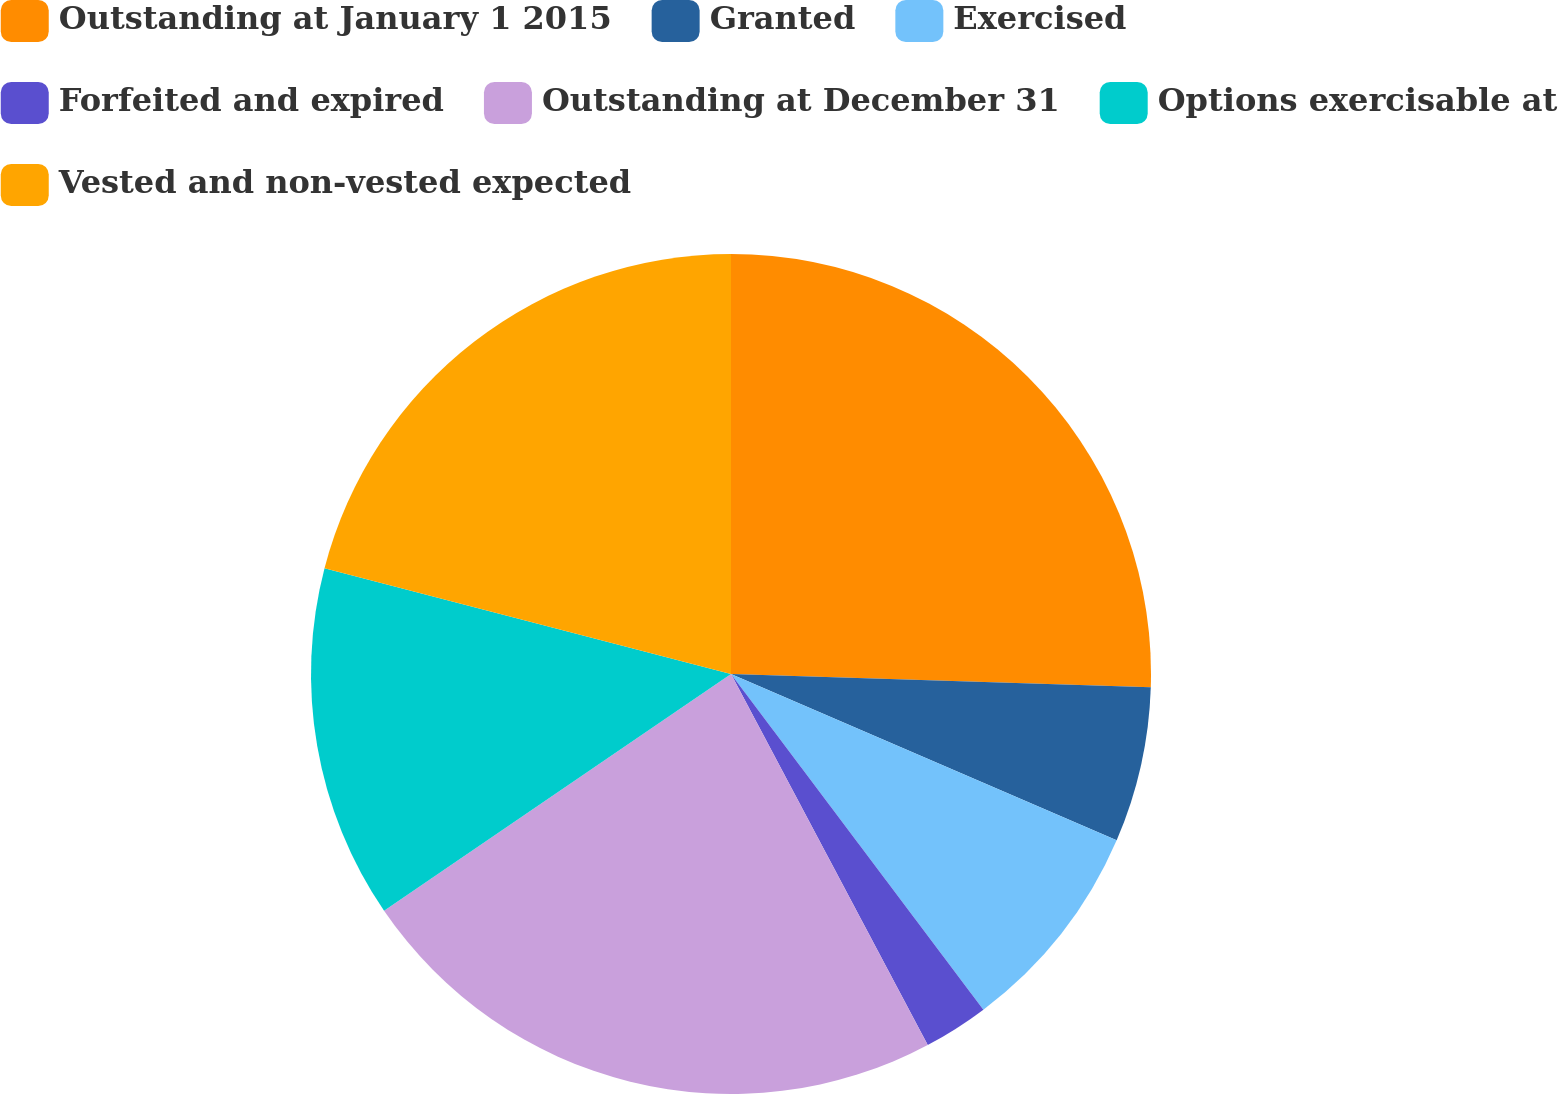Convert chart to OTSL. <chart><loc_0><loc_0><loc_500><loc_500><pie_chart><fcel>Outstanding at January 1 2015<fcel>Granted<fcel>Exercised<fcel>Forfeited and expired<fcel>Outstanding at December 31<fcel>Options exercisable at<fcel>Vested and non-vested expected<nl><fcel>25.5%<fcel>5.98%<fcel>8.26%<fcel>2.5%<fcel>23.23%<fcel>13.58%<fcel>20.95%<nl></chart> 